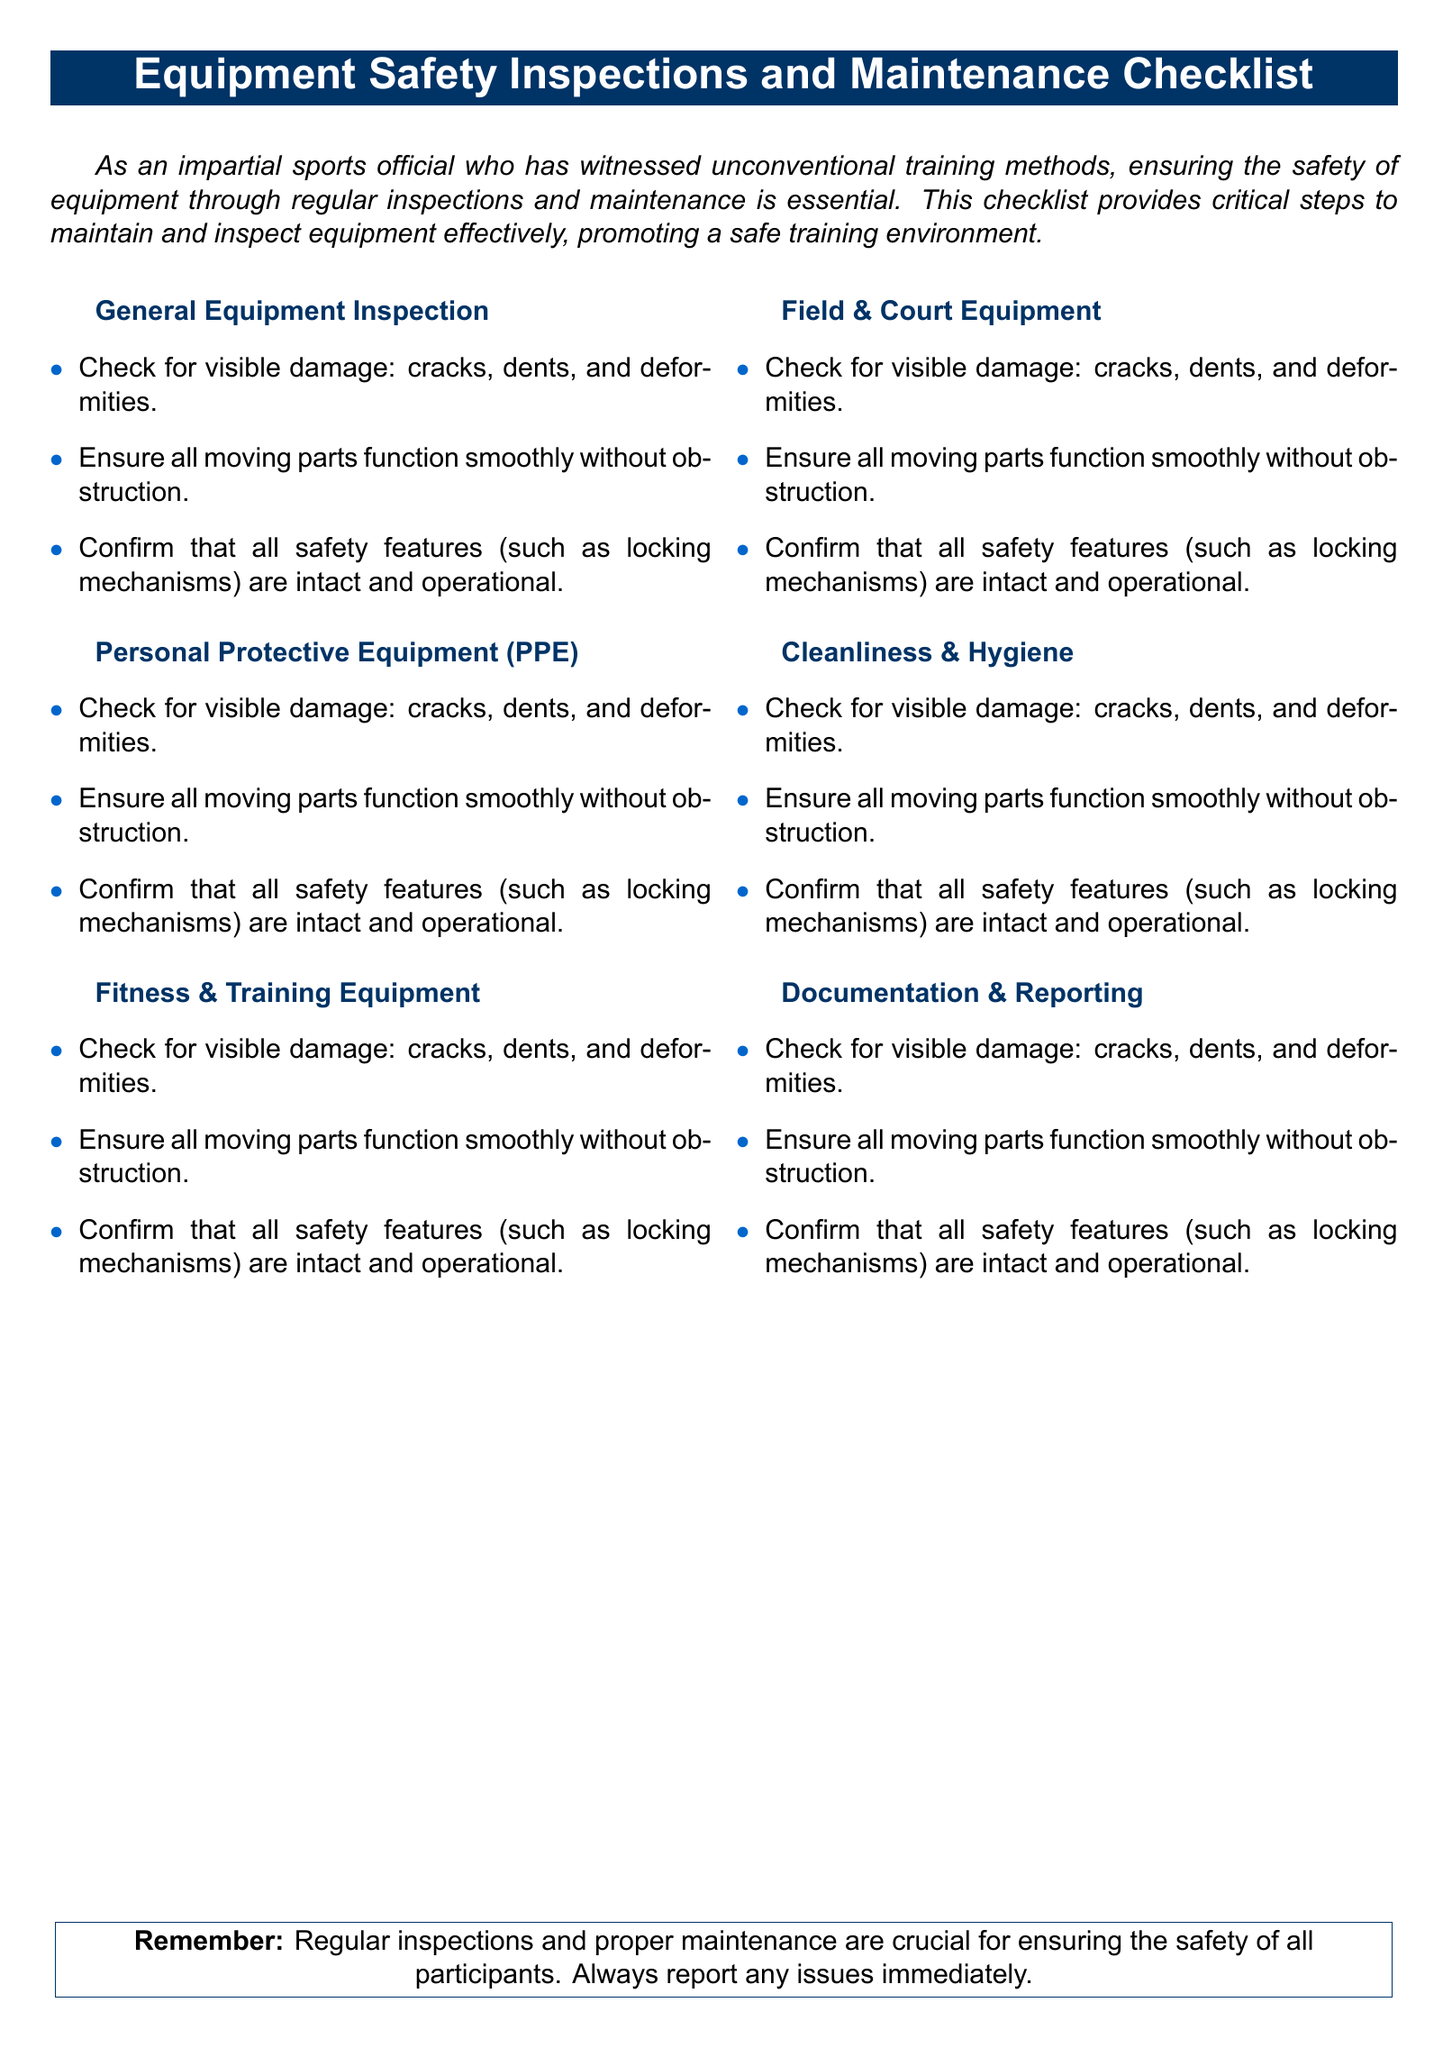What is the title of the document? The title is prominently displayed at the top of the document, indicating its purpose.
Answer: Equipment Safety Inspections and Maintenance Checklist How many sections are there in the checklist? The checklist contains sections that categorize different aspects of equipment safety inspections.
Answer: Six What is one item to check in the General Equipment Inspection section? The document lists multiple items to check for each section, highlighting their importance in the inspection process.
Answer: Visible damage What color is used for the item bullets in the list? The document specifies a distinct color for bullet points to enhance readability.
Answer: Blue What is stated as crucial for ensuring safety in the conclusion? The conclusion emphasizes an essential action that must be taken regarding equipment maintenance.
Answer: Regular inspections Which section specifically addresses Personal Protective Equipment? The document classifies information under various sections, including one focusing solely on safety gear.
Answer: Personal Protective Equipment (PPE) 